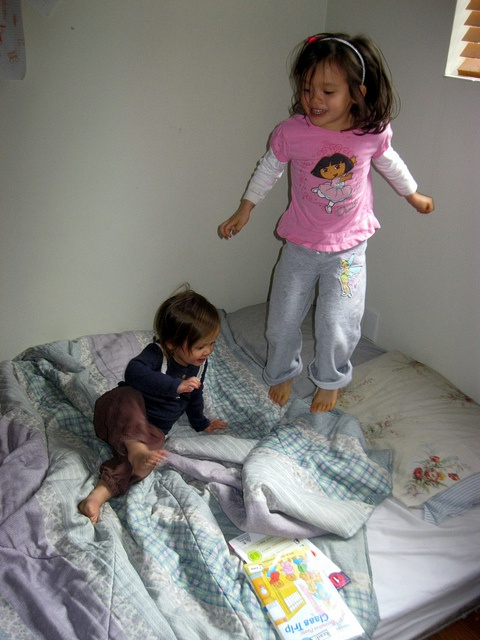Describe the objects in this image and their specific colors. I can see bed in black, gray, darkgray, and lightgray tones, people in black, gray, brown, and darkgray tones, people in black, maroon, and gray tones, book in black, white, khaki, and lightblue tones, and book in black, ivory, darkgray, khaki, and gray tones in this image. 